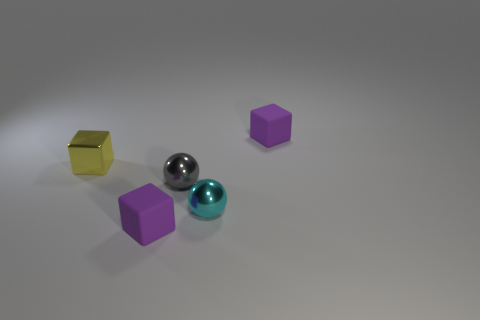Is the number of small cyan spheres that are in front of the small cyan metallic thing the same as the number of small gray things behind the yellow block? Indeed, the number of small cyan spheres positioned in front of the metallic object corresponds precisely to the quantity of small gray objects situated behind the yellow block, with each group containing one item. 